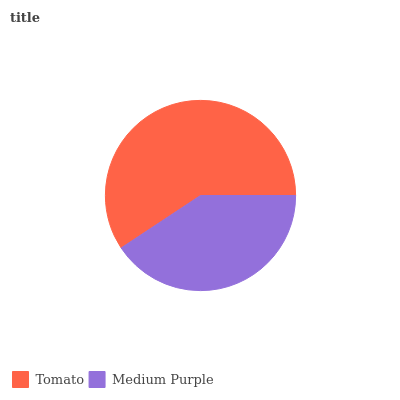Is Medium Purple the minimum?
Answer yes or no. Yes. Is Tomato the maximum?
Answer yes or no. Yes. Is Medium Purple the maximum?
Answer yes or no. No. Is Tomato greater than Medium Purple?
Answer yes or no. Yes. Is Medium Purple less than Tomato?
Answer yes or no. Yes. Is Medium Purple greater than Tomato?
Answer yes or no. No. Is Tomato less than Medium Purple?
Answer yes or no. No. Is Tomato the high median?
Answer yes or no. Yes. Is Medium Purple the low median?
Answer yes or no. Yes. Is Medium Purple the high median?
Answer yes or no. No. Is Tomato the low median?
Answer yes or no. No. 